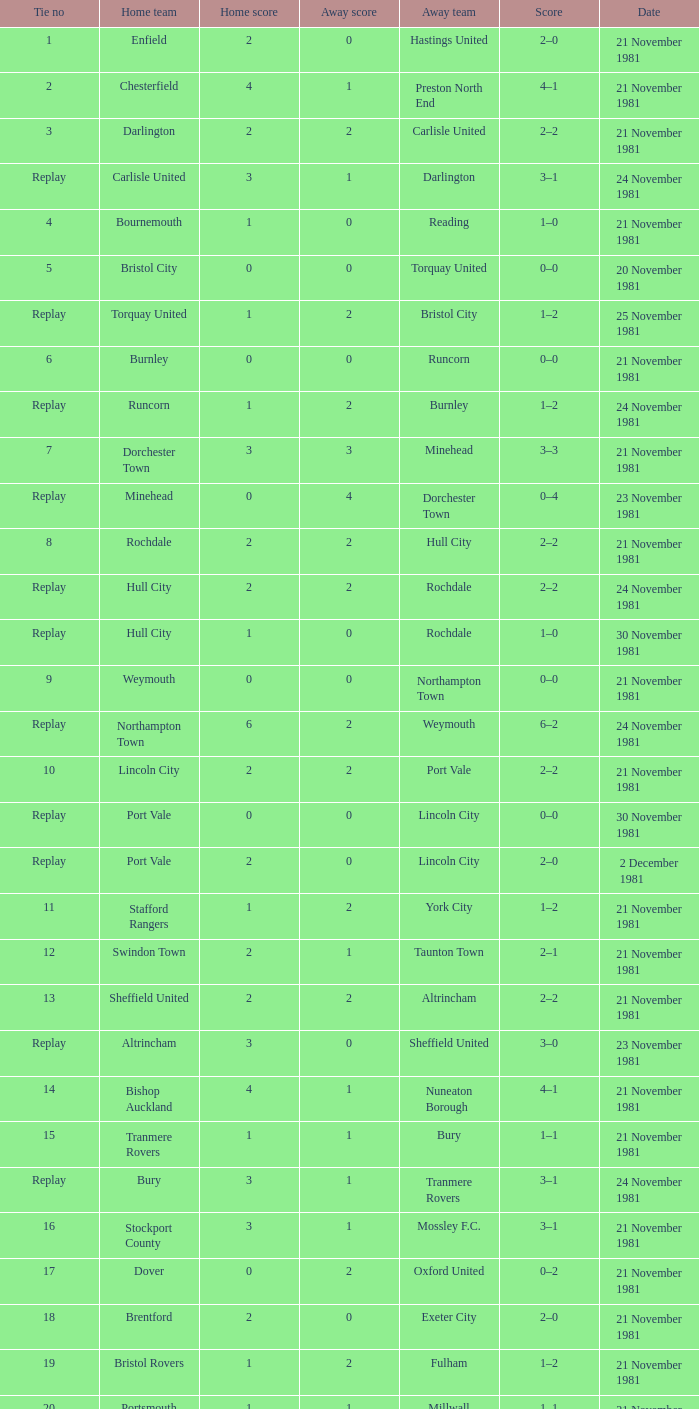When did tie number 4 occur? 21 November 1981. 